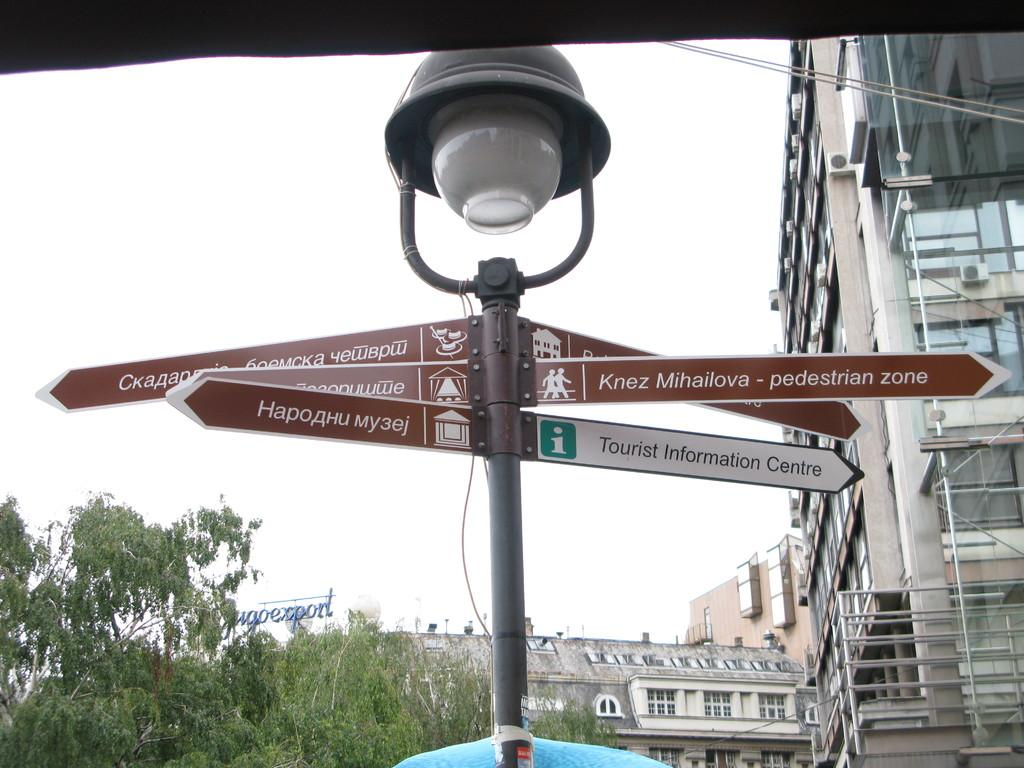What is the main object in the image? There is a lamp post with street direction names in the image. What can be seen in the background of the image? There is a glass building in the background of the image. What type of vegetation is on the left side of the image? There are trees on the left side of the image. How does the lamp post grip the ground in the image? The lamp post does not grip the ground; it is stationary and secured in place. What type of voyage is depicted in the image? There is no voyage depicted in the image; it features a lamp post, a glass building, and trees. 